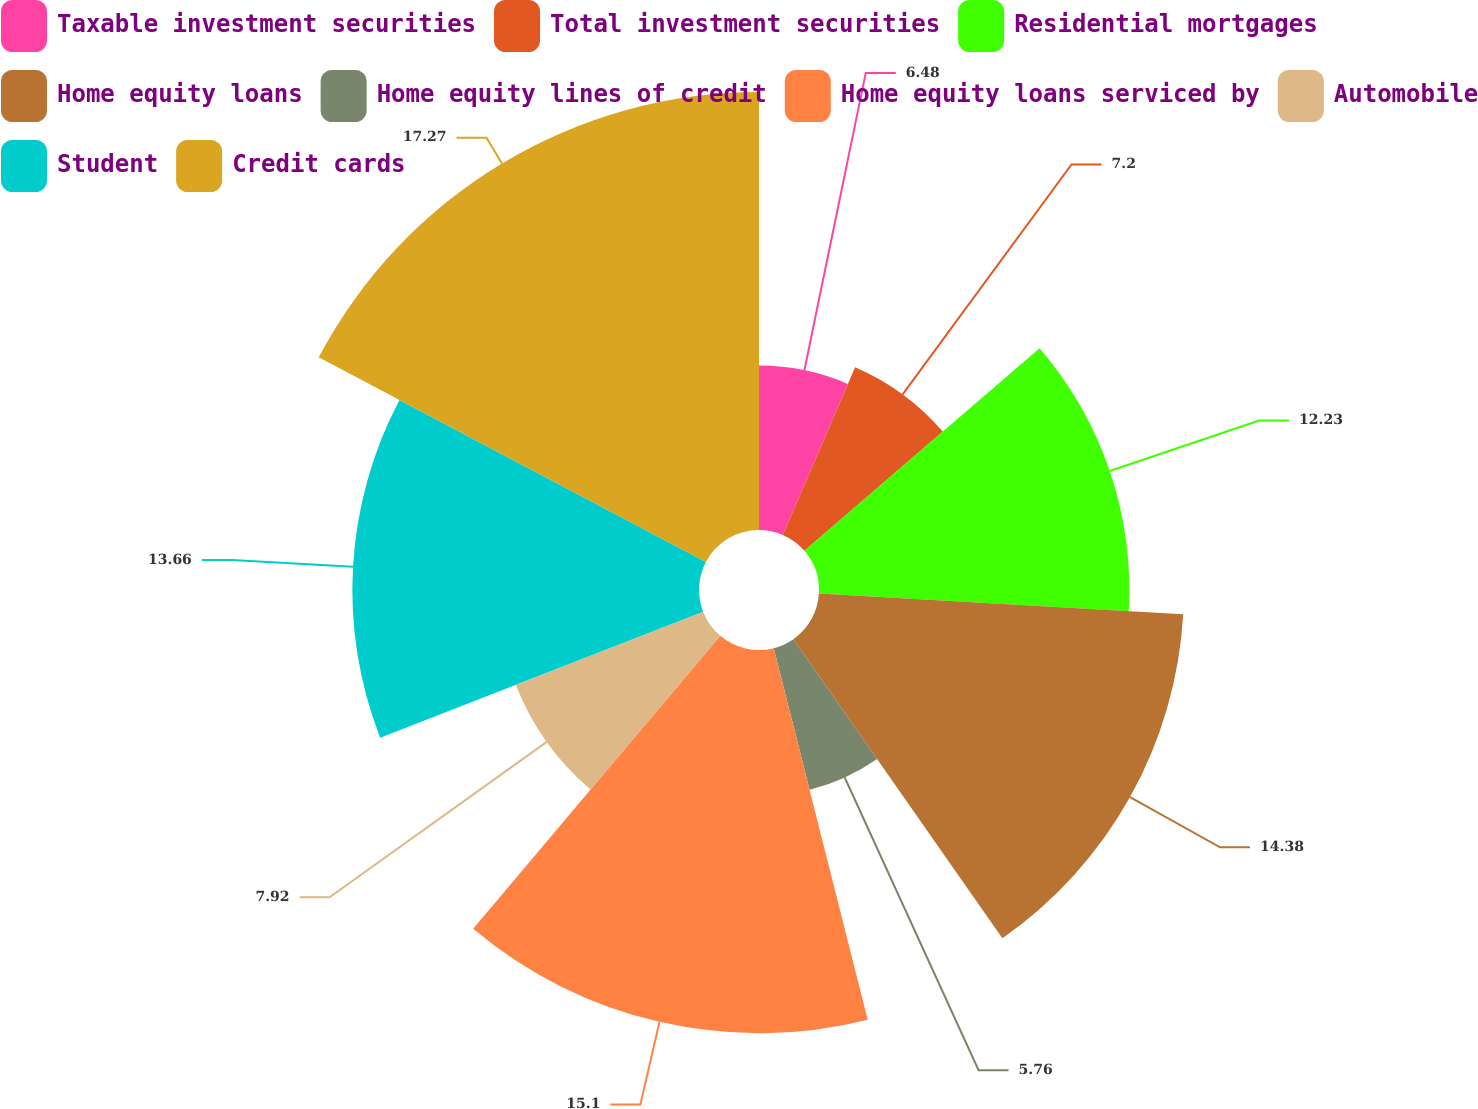Convert chart to OTSL. <chart><loc_0><loc_0><loc_500><loc_500><pie_chart><fcel>Taxable investment securities<fcel>Total investment securities<fcel>Residential mortgages<fcel>Home equity loans<fcel>Home equity lines of credit<fcel>Home equity loans serviced by<fcel>Automobile<fcel>Student<fcel>Credit cards<nl><fcel>6.48%<fcel>7.2%<fcel>12.23%<fcel>14.38%<fcel>5.76%<fcel>15.1%<fcel>7.92%<fcel>13.66%<fcel>17.26%<nl></chart> 